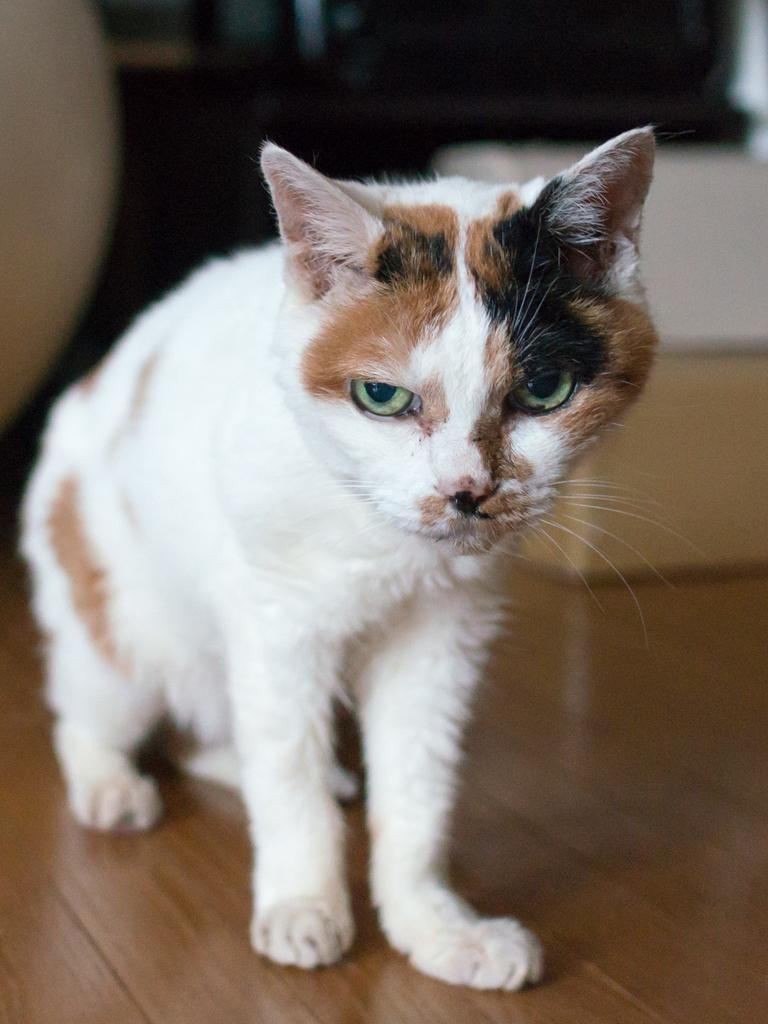What animal is present in the image? There is a cat in the image. Where is the cat located? The cat is standing on a table. Can you describe the background of the image? The background of the image is blurred. What type of addition problem can be solved using the numbers on the cat's locket in the image? There is no locket present on the cat in the image, so no addition problem can be solved using it. 